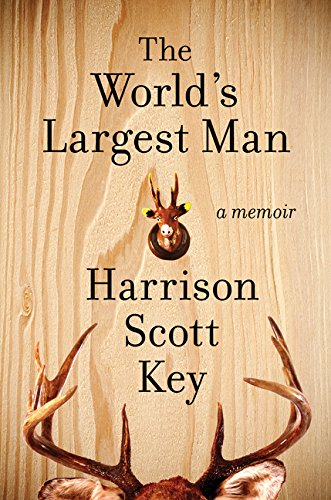What is the title of this book? The title of the book displayed in the image is 'The World's Largest Man: A Memoir', a reflective and often comedic recount of the author's life experiences. 